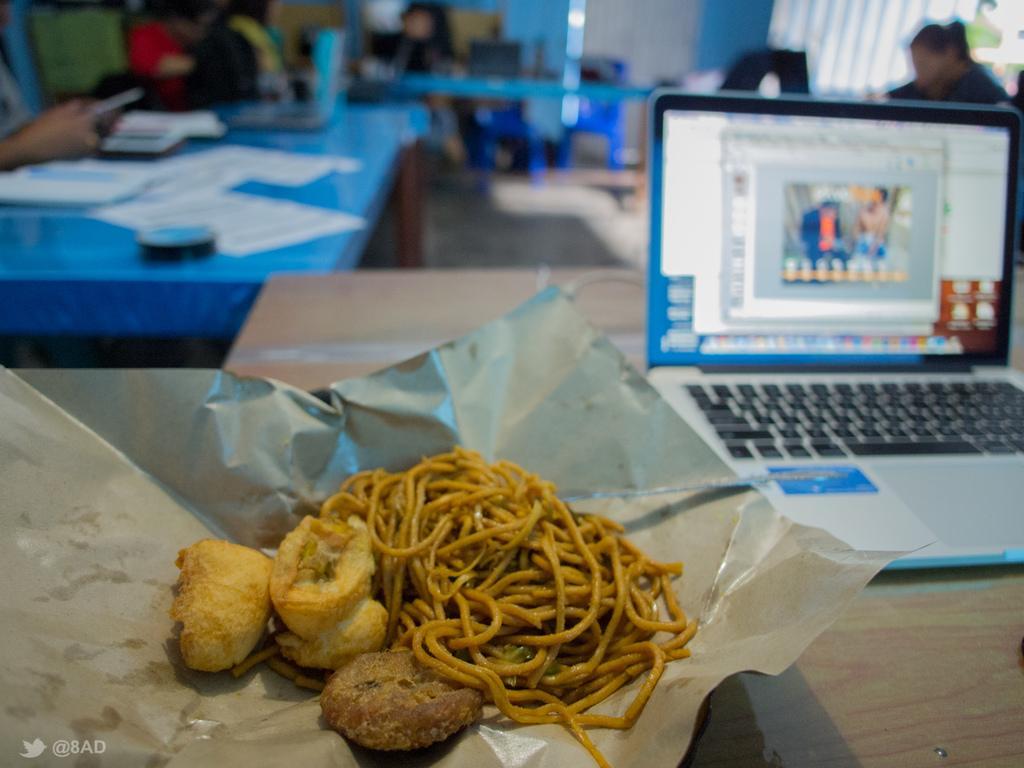Could you give a brief overview of what you see in this image? In this picture there is a table on the right side of the image, on which there is a laptop and there is a plate in the center of the image, on the table, which contains noodles in it and there are other tablets, laptops, and people at the top side of the image. 